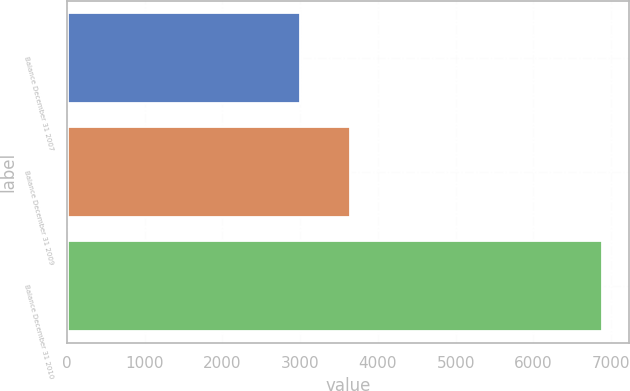<chart> <loc_0><loc_0><loc_500><loc_500><bar_chart><fcel>Balance December 31 2007<fcel>Balance December 31 2009<fcel>Balance December 31 2010<nl><fcel>3002<fcel>3636<fcel>6881<nl></chart> 